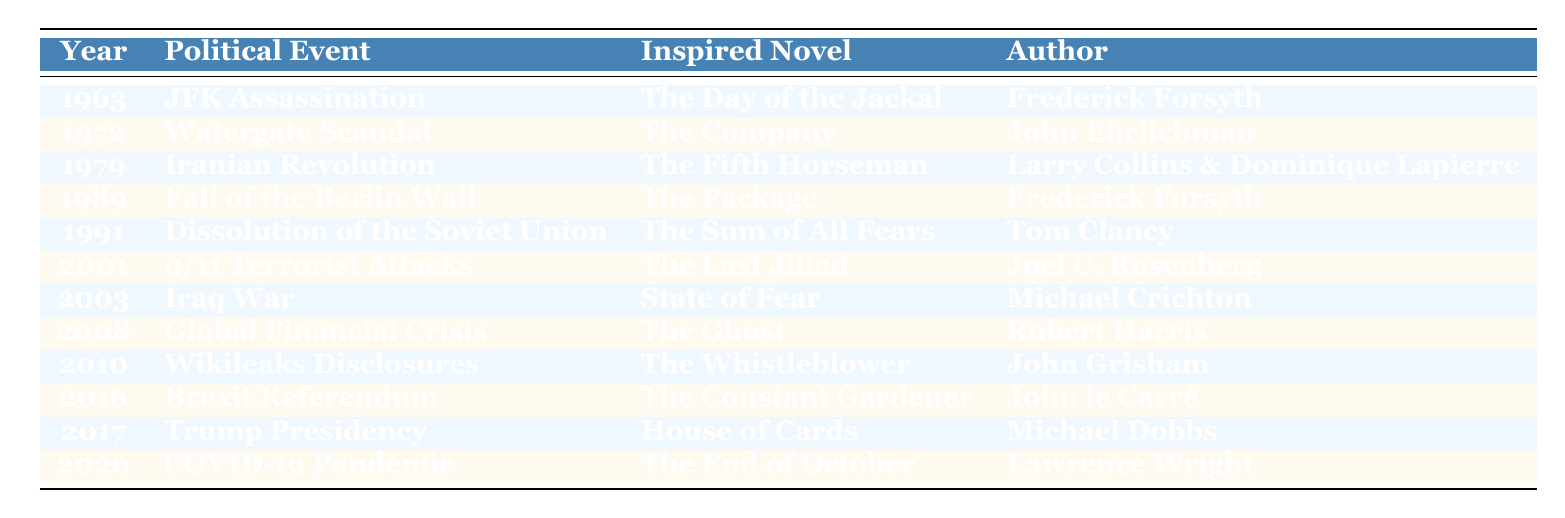What political event occurred in 2001? The table lists "9/11 Terrorist Attacks" as the political event for the year 2001.
Answer: 9/11 Terrorist Attacks Who wrote "The Day of the Jackal"? According to the table, "The Day of the Jackal" was written by Frederick Forsyth.
Answer: Frederick Forsyth Which novel was inspired by the Brexit Referendum? The table indicates that "The Constant Gardener" was inspired by the Brexit Referendum in 2016.
Answer: The Constant Gardener Was "The Sum of All Fears" inspired by the Fall of the Berlin Wall? The table shows that "The Sum of All Fears" was inspired by the Dissolution of the Soviet Union, not the Fall of the Berlin Wall, so this statement is false.
Answer: No What is the range of years in which the events listed occurred? The range can be calculated from the earliest year (1963) to the latest year (2020): 2020 - 1963 = 57 years.
Answer: 57 years Identify the political event that inspired "State of Fear." Referring to the table, "State of Fear" was inspired by the Iraq War in 2003.
Answer: Iraq War How many novels were inspired by events that occurred before 2000? The table shows that there are 6 events before the year 2000: JFK Assassination, Watergate Scandal, Iranian Revolution, Fall of the Berlin Wall, and Dissolution of the Soviet Union, along with the 9/11 attacks. So, there are 6 novels inspired.
Answer: 6 novels Which author has written more than one novel based on political events listed in the table? By reviewing the table, only Frederick Forsyth has written two novels: "The Day of the Jackal" and "The Package."
Answer: Frederick Forsyth List all political events that occurred in the 21st century and the corresponding novels. The events in the 21st century are: 2001 - 9/11 Terrorist Attacks (The Last Jihad), 2003 - Iraq War (State of Fear), 2008 - Global Financial Crisis (The Ghost), 2010 - Wikileaks Disclosures (The Whistleblower), 2016 - Brexit Referendum (The Constant Gardener), 2017 - Trump Presidency (House of Cards), and 2020 - COVID-19 Pandemic (The End of October).
Answer: 7 events What is the total number of unique authors listed in the table? The table lists 12 entries, and they feature 11 unique authors when accounting for Frederick Forsyth appearing twice.
Answer: 11 unique authors 